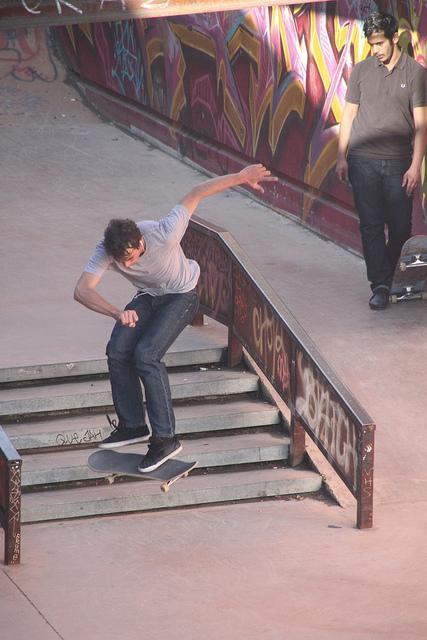How many people in the picture?
Give a very brief answer. 2. How many steps are visible?
Give a very brief answer. 5. How many steps are there?
Give a very brief answer. 5. How many people are visible?
Give a very brief answer. 2. 